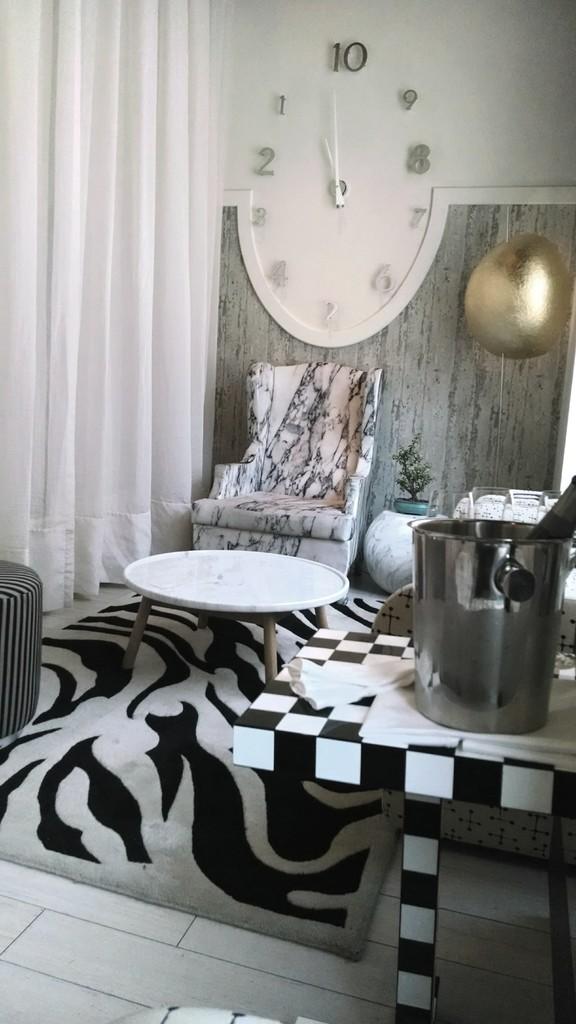What is the time shown?
Provide a short and direct response. Unanswerable. 